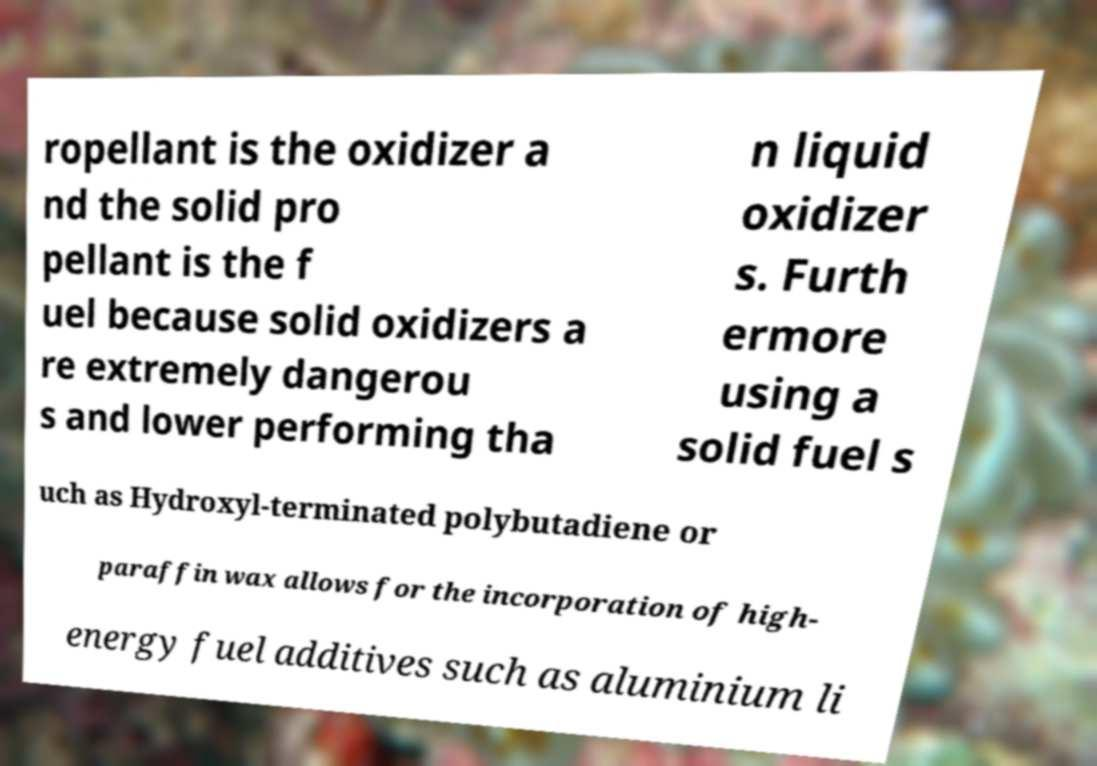There's text embedded in this image that I need extracted. Can you transcribe it verbatim? ropellant is the oxidizer a nd the solid pro pellant is the f uel because solid oxidizers a re extremely dangerou s and lower performing tha n liquid oxidizer s. Furth ermore using a solid fuel s uch as Hydroxyl-terminated polybutadiene or paraffin wax allows for the incorporation of high- energy fuel additives such as aluminium li 